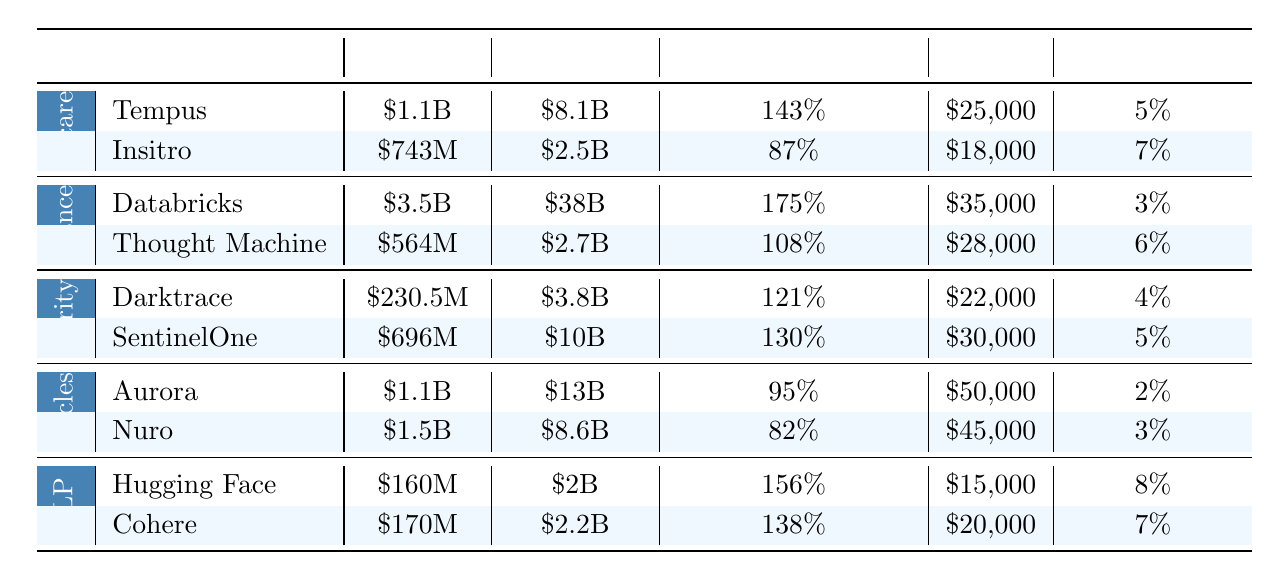What is the highest funding amount listed in the table? The highest funding amount in the table is found in the Finance domain, with Databricks receiving $3.5B.
Answer: $3.5B Which startup has the lowest customer acquisition cost? By comparing the Customer Acquisition Cost across all startups, Hugging Face has the lowest cost at $15,000.
Answer: $15,000 What is the average valuation for startups in the Cybersecurity domain? The valuations for the startups Darktrace ($3.8B) and SentinelOne ($10B) are summed up: $3.8B + $10B = $13.8B. There are 2 startups, so the average valuation is $13.8B / 2 = $6.9B.
Answer: $6.9B Which startup has the highest revenue growth? Checking the Revenue Growth percentages, Databricks shows the highest percentage at 175%.
Answer: 175% What is the total funding for startups in the Autonomous Vehicles domain? The funding amounts for the startups are Aurora ($1.1B) and Nuro ($1.5B). Summing them gives $1.1B + $1.5B = $2.6B.
Answer: $2.6B Is it true that all startups in the Finance domain have a churn rate lower than 6%? The churn rates for Databricks (3%) and Thought Machine (6%) show that Thought Machine equals 6%, so not all are below 6%.
Answer: No Which domain has the startup with the highest revenue growth and what is that percentage? The Finance domain has Databricks with the highest revenue growth at 175%. A review across all domains confirms this.
Answer: 175% What is the difference in valuation between the highest and lowest valued startup in Healthcare? In Healthcare, Tempus is valued at $8.1B and Insitro at $2.5B. The difference is $8.1B - $2.5B = $5.6B.
Answer: $5.6B Which startup has the highest churn rate and what is that rate? The churn rates are inspected, with Hugging Face having the highest at 8%.
Answer: 8% Are there any startups with a customer acquisition cost exceeding $30,000? The customer acquisition costs are reviewed, finding that both Databricks ($35,000) and Aurora ($50,000) exceed $30,000.
Answer: Yes 